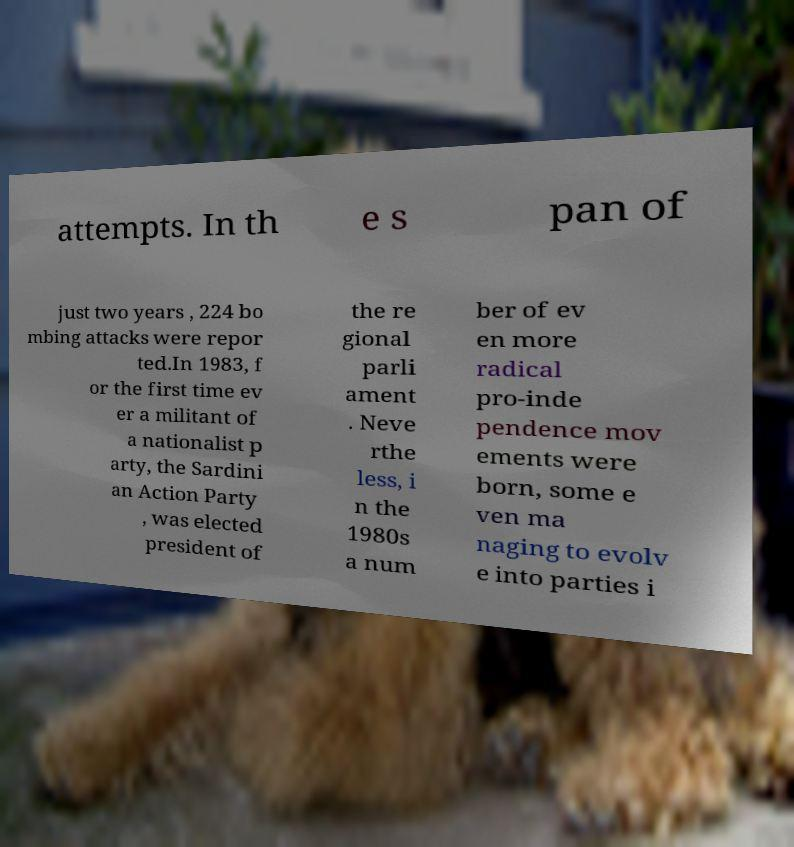I need the written content from this picture converted into text. Can you do that? attempts. In th e s pan of just two years , 224 bo mbing attacks were repor ted.In 1983, f or the first time ev er a militant of a nationalist p arty, the Sardini an Action Party , was elected president of the re gional parli ament . Neve rthe less, i n the 1980s a num ber of ev en more radical pro-inde pendence mov ements were born, some e ven ma naging to evolv e into parties i 